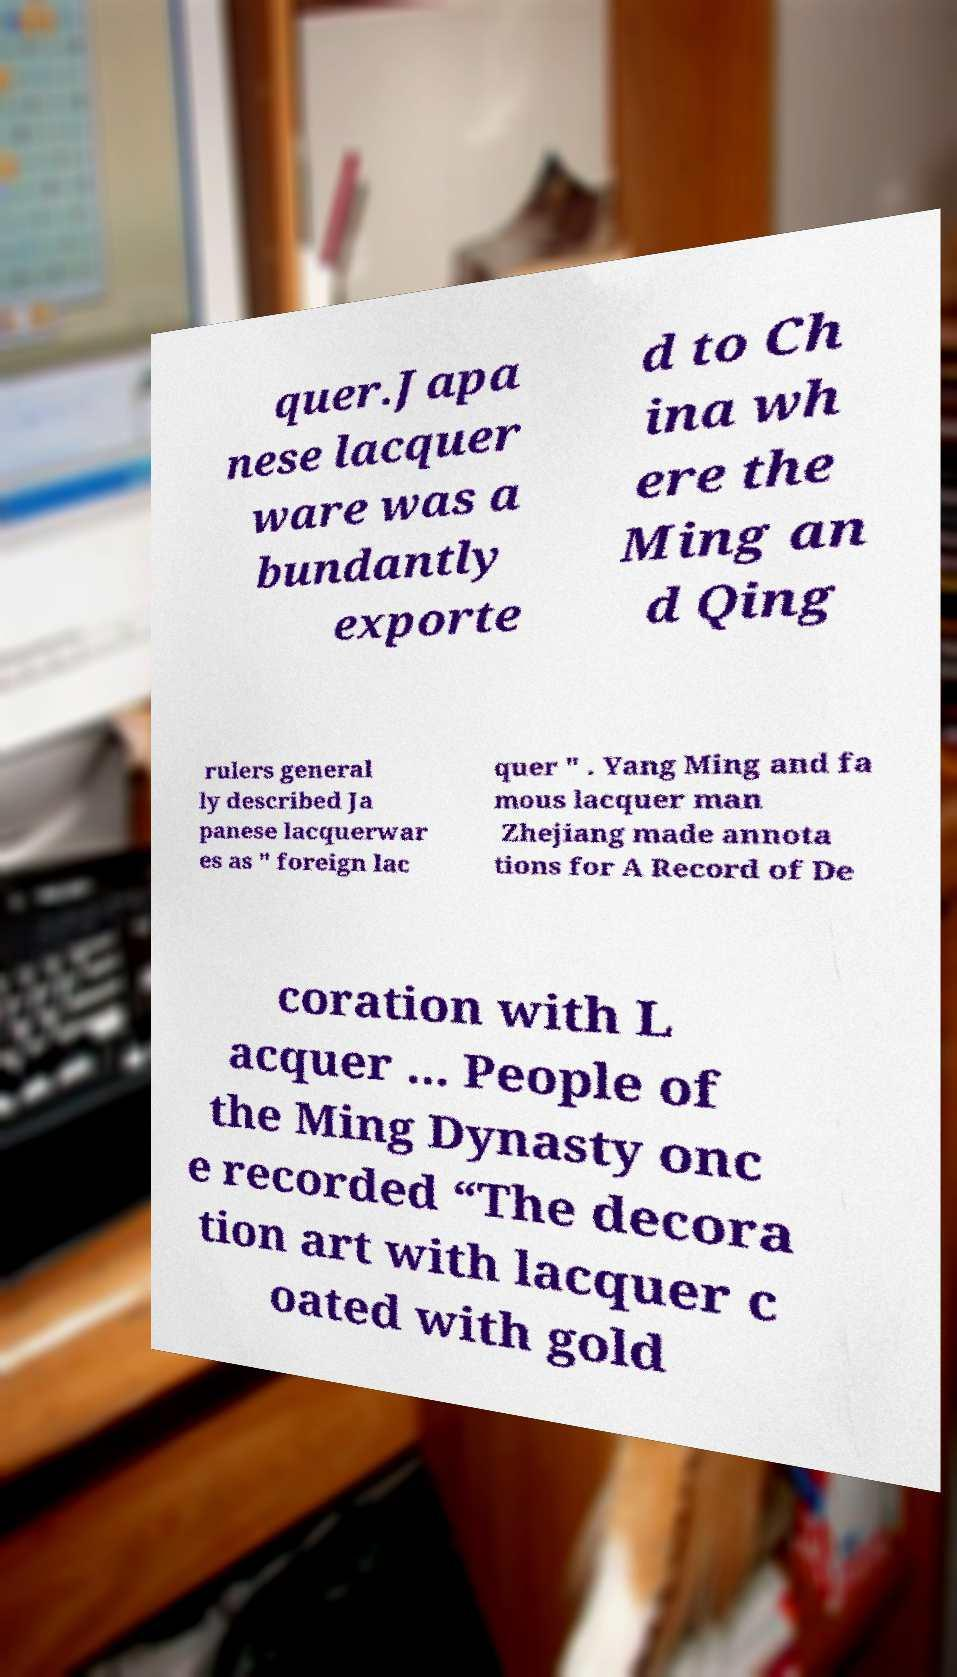I need the written content from this picture converted into text. Can you do that? quer.Japa nese lacquer ware was a bundantly exporte d to Ch ina wh ere the Ming an d Qing rulers general ly described Ja panese lacquerwar es as " foreign lac quer " . Yang Ming and fa mous lacquer man Zhejiang made annota tions for A Record of De coration with L acquer ... People of the Ming Dynasty onc e recorded “The decora tion art with lacquer c oated with gold 